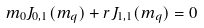<formula> <loc_0><loc_0><loc_500><loc_500>m _ { 0 } J _ { 0 , 1 } ( m _ { q } ) + r J _ { 1 , 1 } ( m _ { q } ) = 0</formula> 